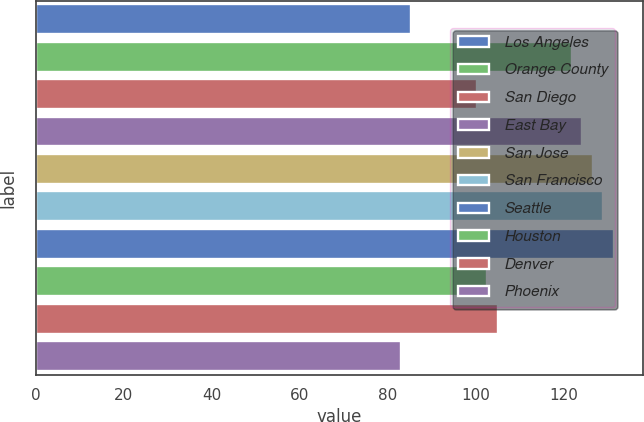<chart> <loc_0><loc_0><loc_500><loc_500><bar_chart><fcel>Los Angeles<fcel>Orange County<fcel>San Diego<fcel>East Bay<fcel>San Jose<fcel>San Francisco<fcel>Seattle<fcel>Houston<fcel>Denver<fcel>Phoenix<nl><fcel>85.4<fcel>121.8<fcel>100.2<fcel>124.2<fcel>126.6<fcel>129<fcel>131.4<fcel>102.6<fcel>105<fcel>83<nl></chart> 